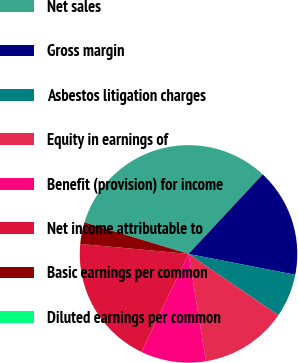<chart> <loc_0><loc_0><loc_500><loc_500><pie_chart><fcel>Net sales<fcel>Gross margin<fcel>Asbestos litigation charges<fcel>Equity in earnings of<fcel>Benefit (provision) for income<fcel>Net income attributable to<fcel>Basic earnings per common<fcel>Diluted earnings per common<nl><fcel>32.24%<fcel>16.13%<fcel>6.46%<fcel>12.9%<fcel>9.68%<fcel>19.35%<fcel>3.23%<fcel>0.01%<nl></chart> 